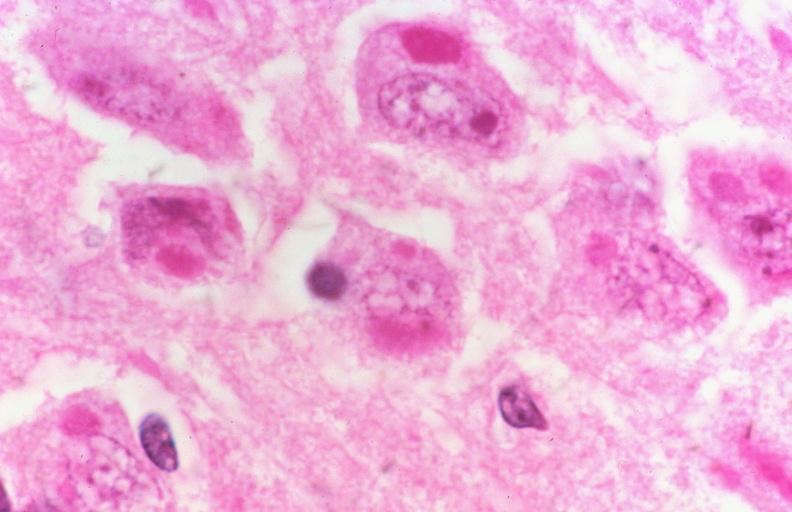what does this image show?
Answer the question using a single word or phrase. Rabies 